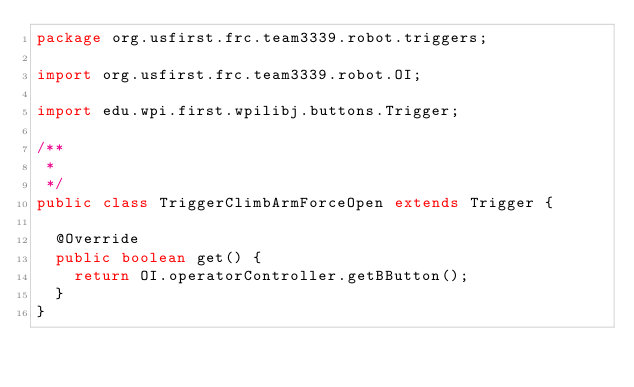<code> <loc_0><loc_0><loc_500><loc_500><_Java_>package org.usfirst.frc.team3339.robot.triggers;

import org.usfirst.frc.team3339.robot.OI;

import edu.wpi.first.wpilibj.buttons.Trigger;

/**
 *
 */
public class TriggerClimbArmForceOpen extends Trigger {

	@Override
	public boolean get() {
		return OI.operatorController.getBButton();
	}
}
</code> 